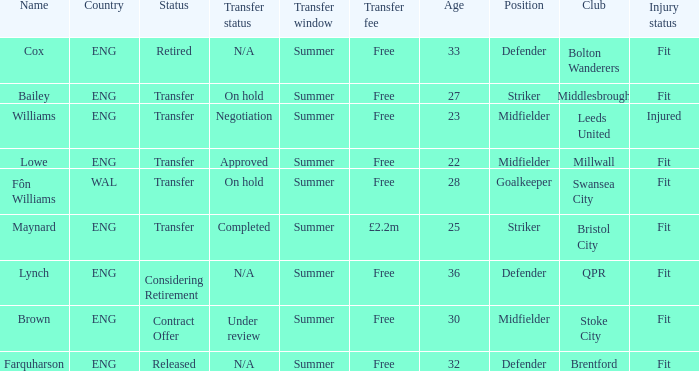What is Brown's transfer window? Summer. 